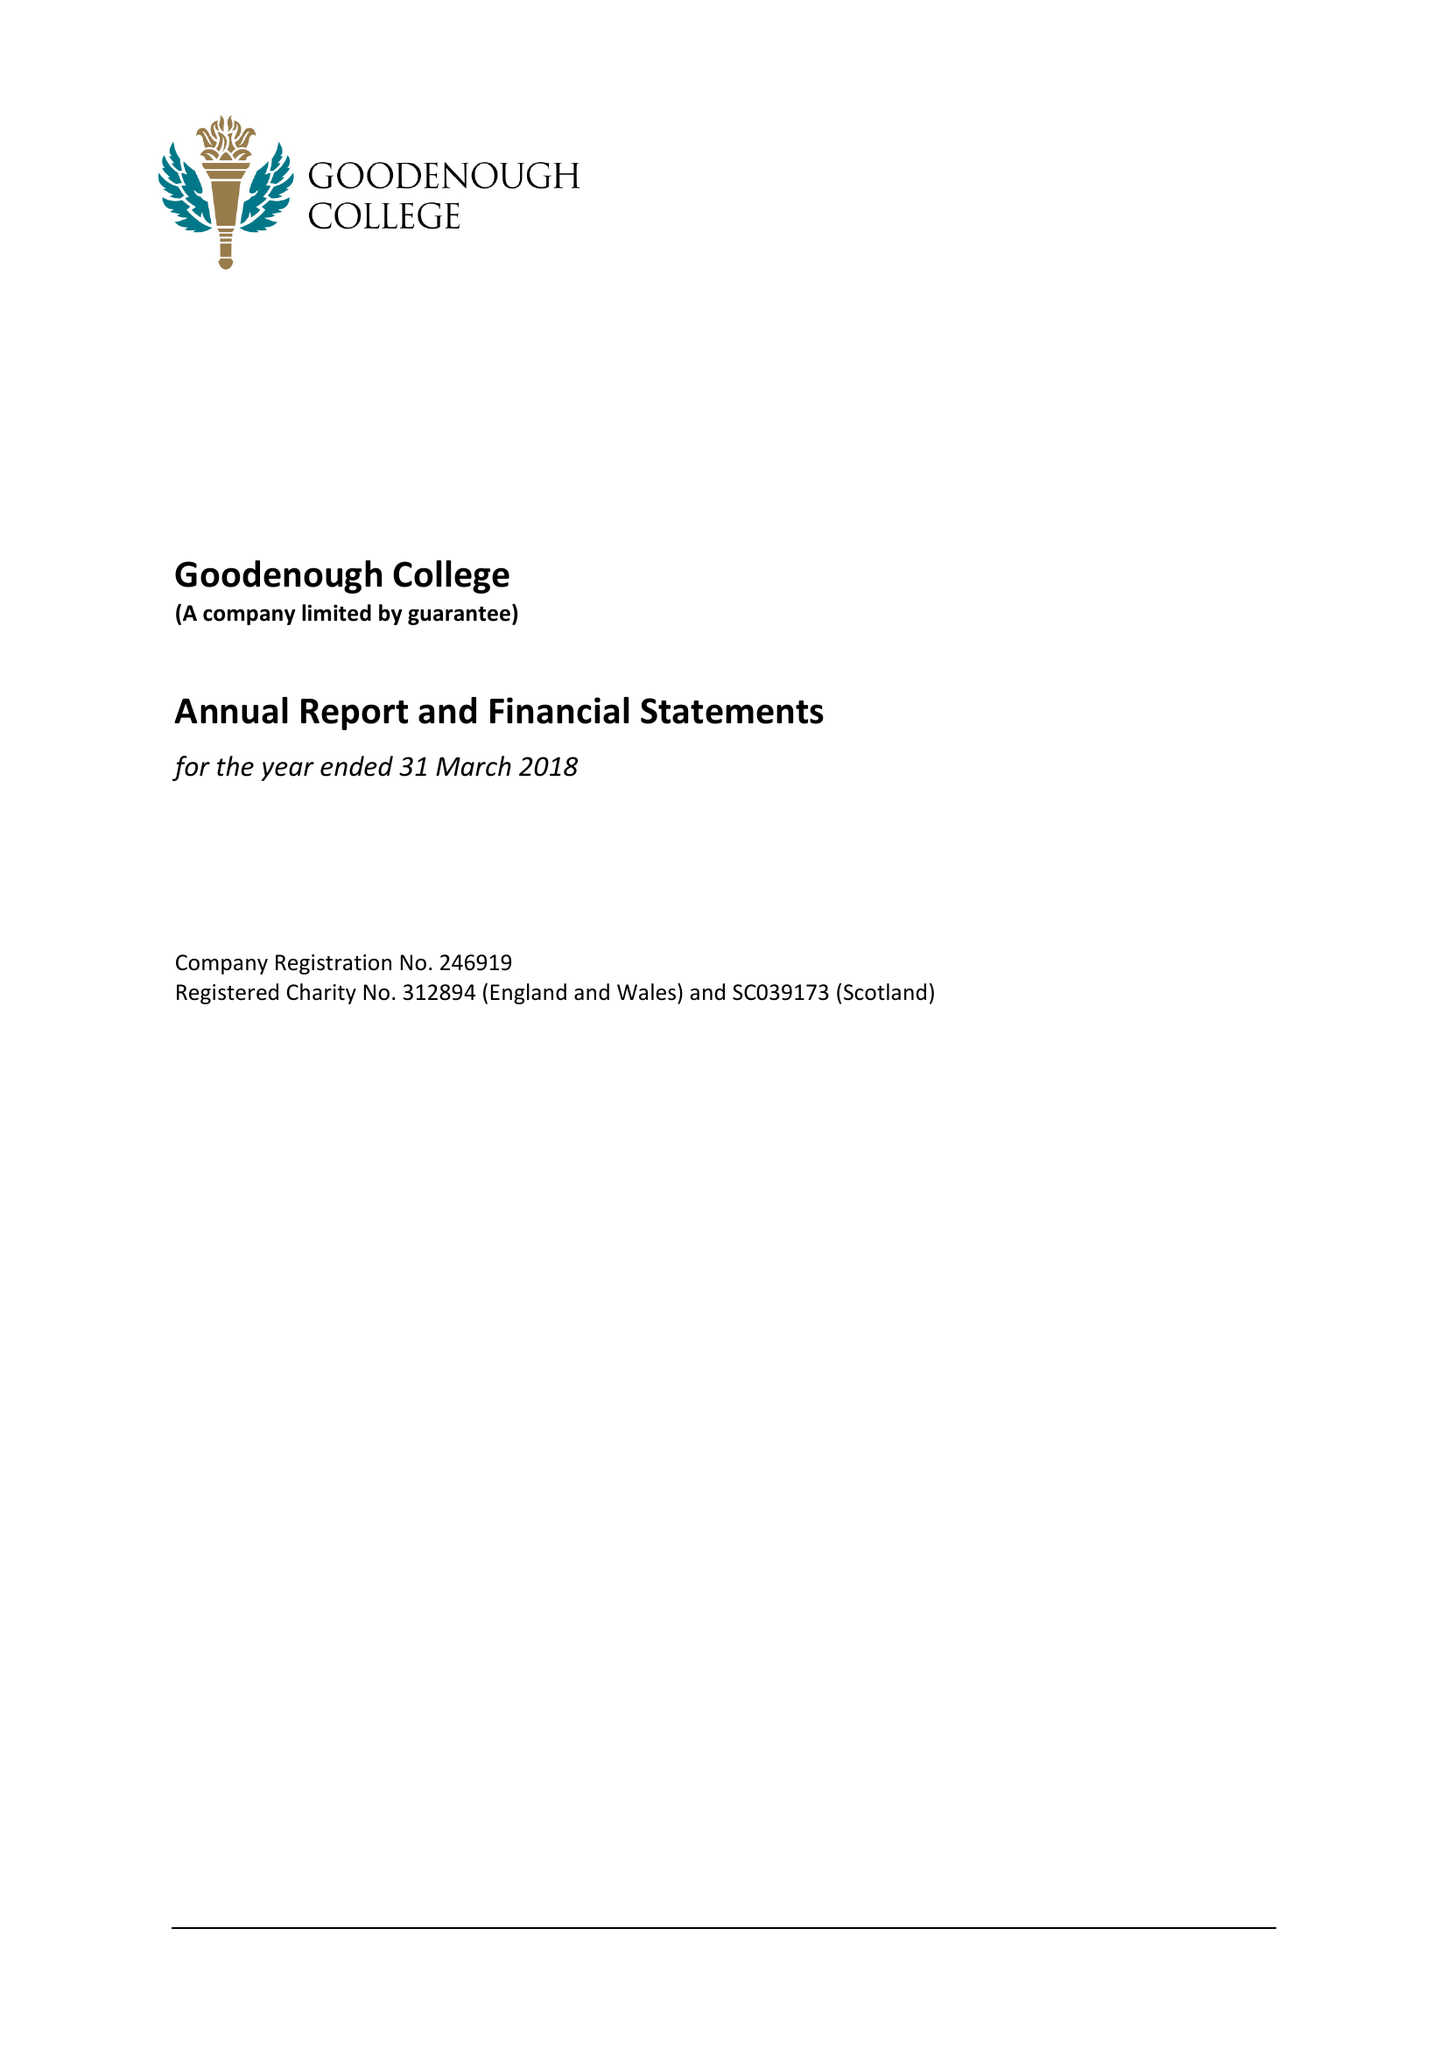What is the value for the income_annually_in_british_pounds?
Answer the question using a single word or phrase. 12575000.00 